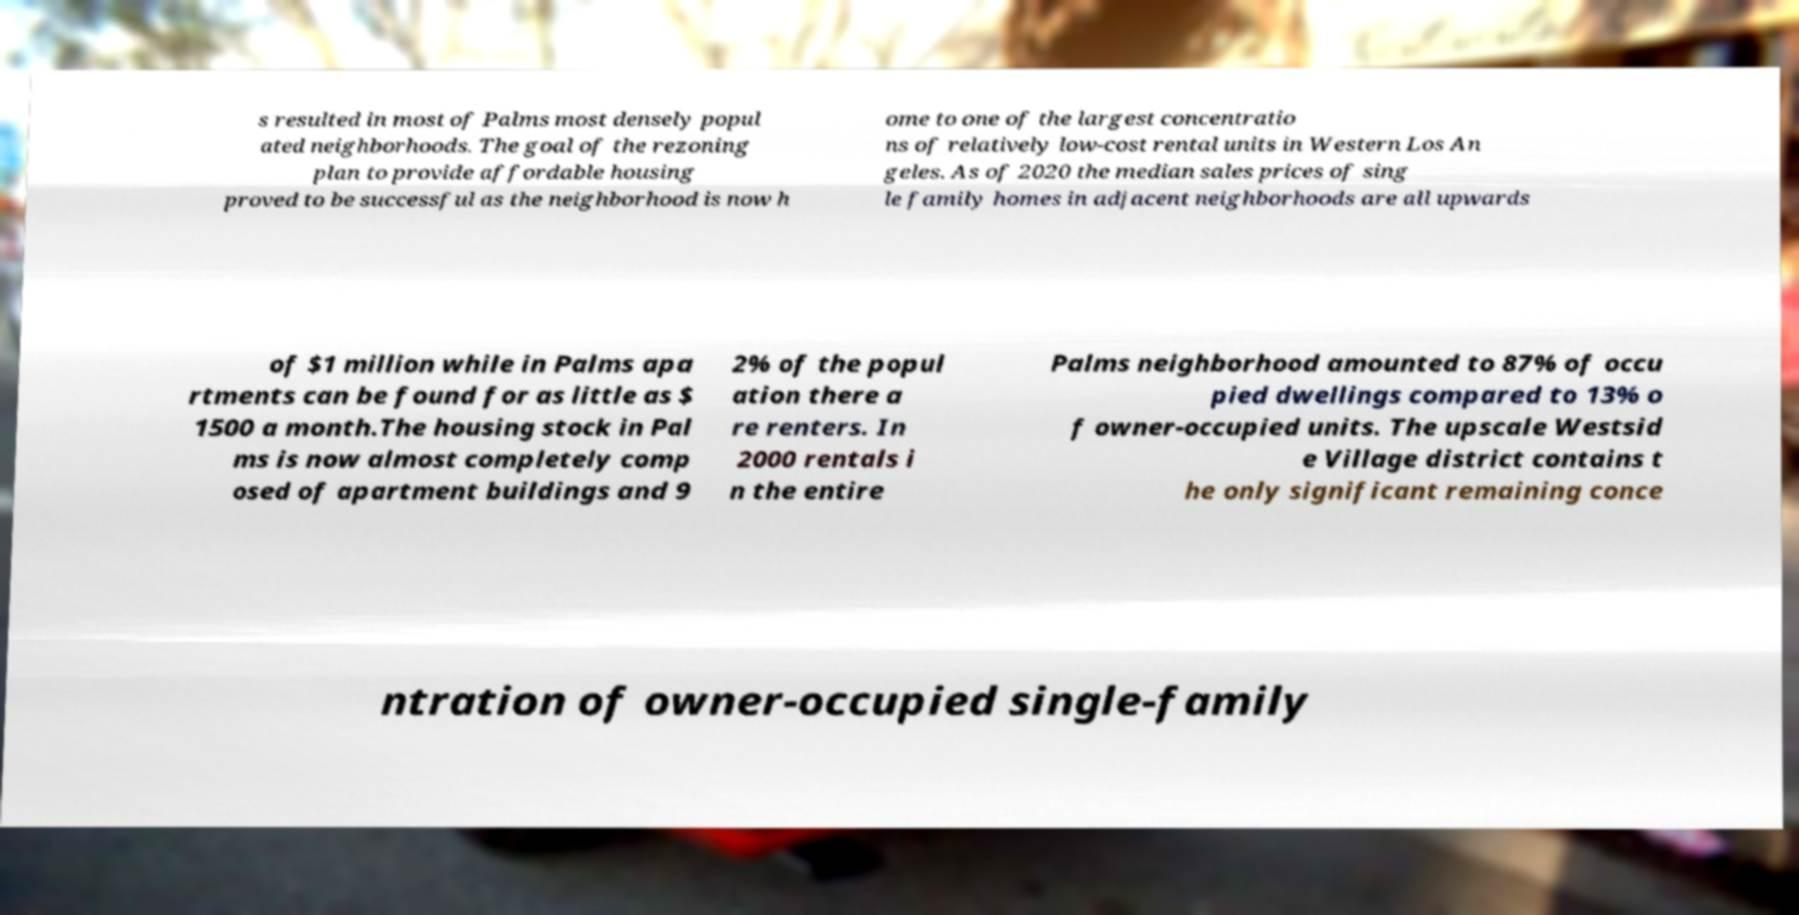Could you assist in decoding the text presented in this image and type it out clearly? s resulted in most of Palms most densely popul ated neighborhoods. The goal of the rezoning plan to provide affordable housing proved to be successful as the neighborhood is now h ome to one of the largest concentratio ns of relatively low-cost rental units in Western Los An geles. As of 2020 the median sales prices of sing le family homes in adjacent neighborhoods are all upwards of $1 million while in Palms apa rtments can be found for as little as $ 1500 a month.The housing stock in Pal ms is now almost completely comp osed of apartment buildings and 9 2% of the popul ation there a re renters. In 2000 rentals i n the entire Palms neighborhood amounted to 87% of occu pied dwellings compared to 13% o f owner-occupied units. The upscale Westsid e Village district contains t he only significant remaining conce ntration of owner-occupied single-family 